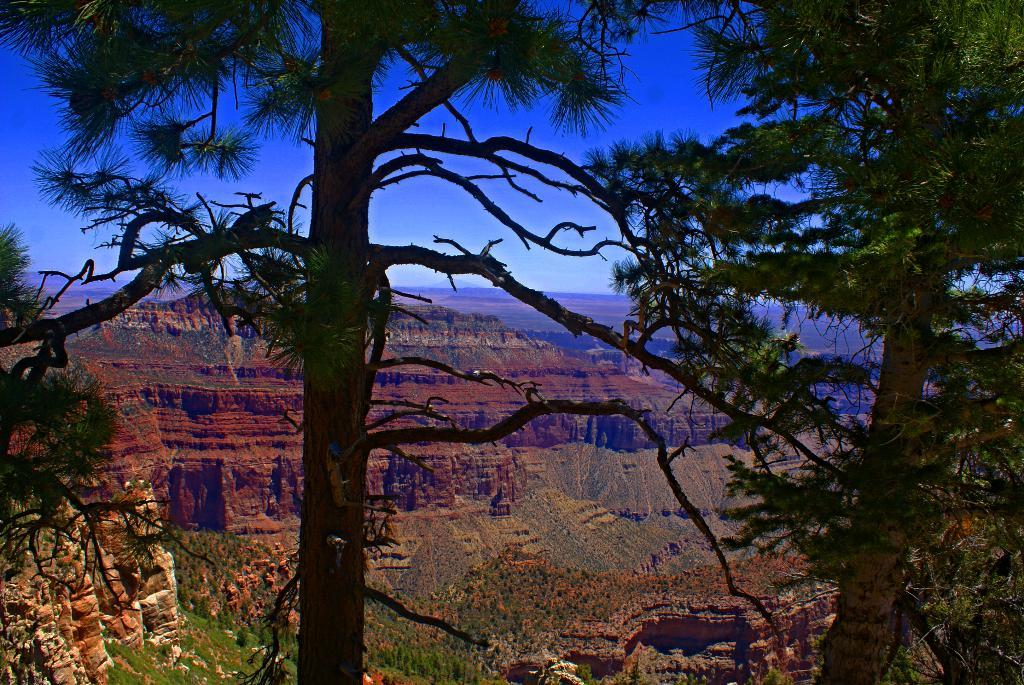What type of vegetation can be seen in the image? There are trees in the image. What geographical features are present in the image? There are hills in the image. What is visible in the background of the image? The sky is visible in the background of the image. Can you see a hose watering the trees in the image? There is no hose present in the image; it only features trees, hills, and the sky. What type of rice is growing on the hills in the image? There is no rice visible in the image; it only features trees and hills. 